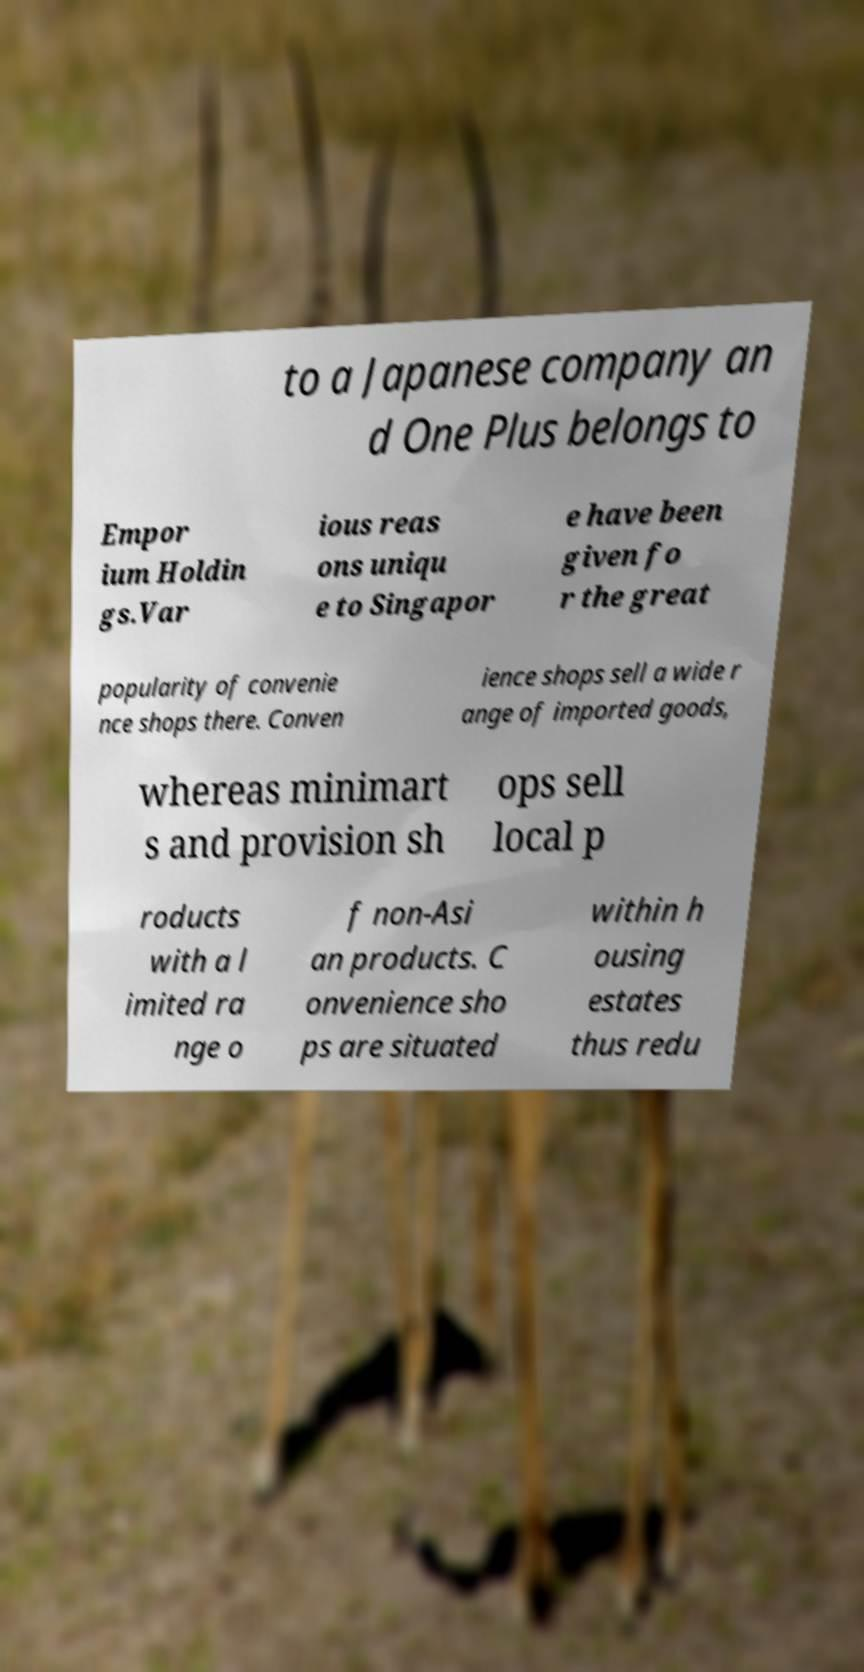I need the written content from this picture converted into text. Can you do that? to a Japanese company an d One Plus belongs to Empor ium Holdin gs.Var ious reas ons uniqu e to Singapor e have been given fo r the great popularity of convenie nce shops there. Conven ience shops sell a wide r ange of imported goods, whereas minimart s and provision sh ops sell local p roducts with a l imited ra nge o f non-Asi an products. C onvenience sho ps are situated within h ousing estates thus redu 